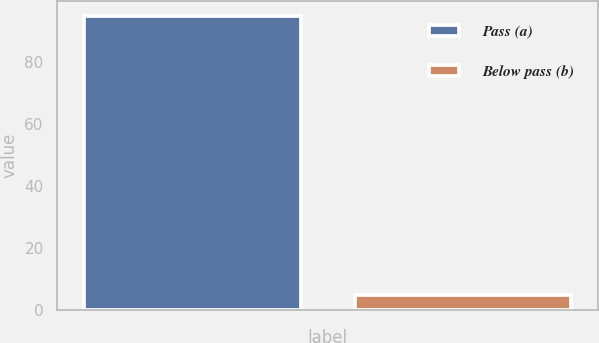Convert chart to OTSL. <chart><loc_0><loc_0><loc_500><loc_500><bar_chart><fcel>Pass (a)<fcel>Below pass (b)<nl><fcel>95<fcel>5<nl></chart> 